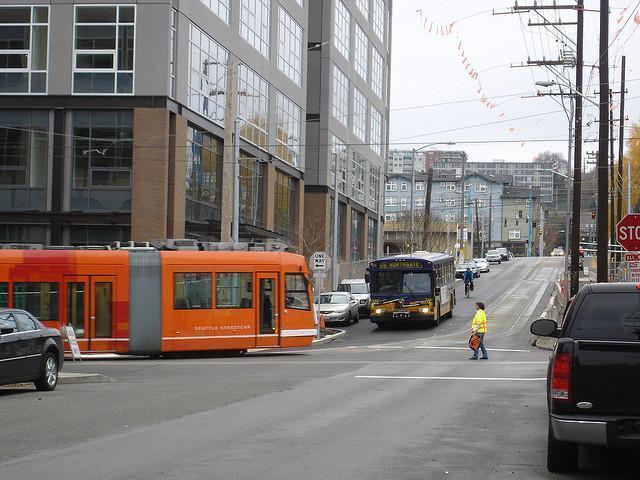What is the reason for the woman in yellow standing in the street here?
From the following set of four choices, select the accurate answer to respond to the question.
Options: Drunk test, road construction, police stop, trapping robbers. Road construction. 